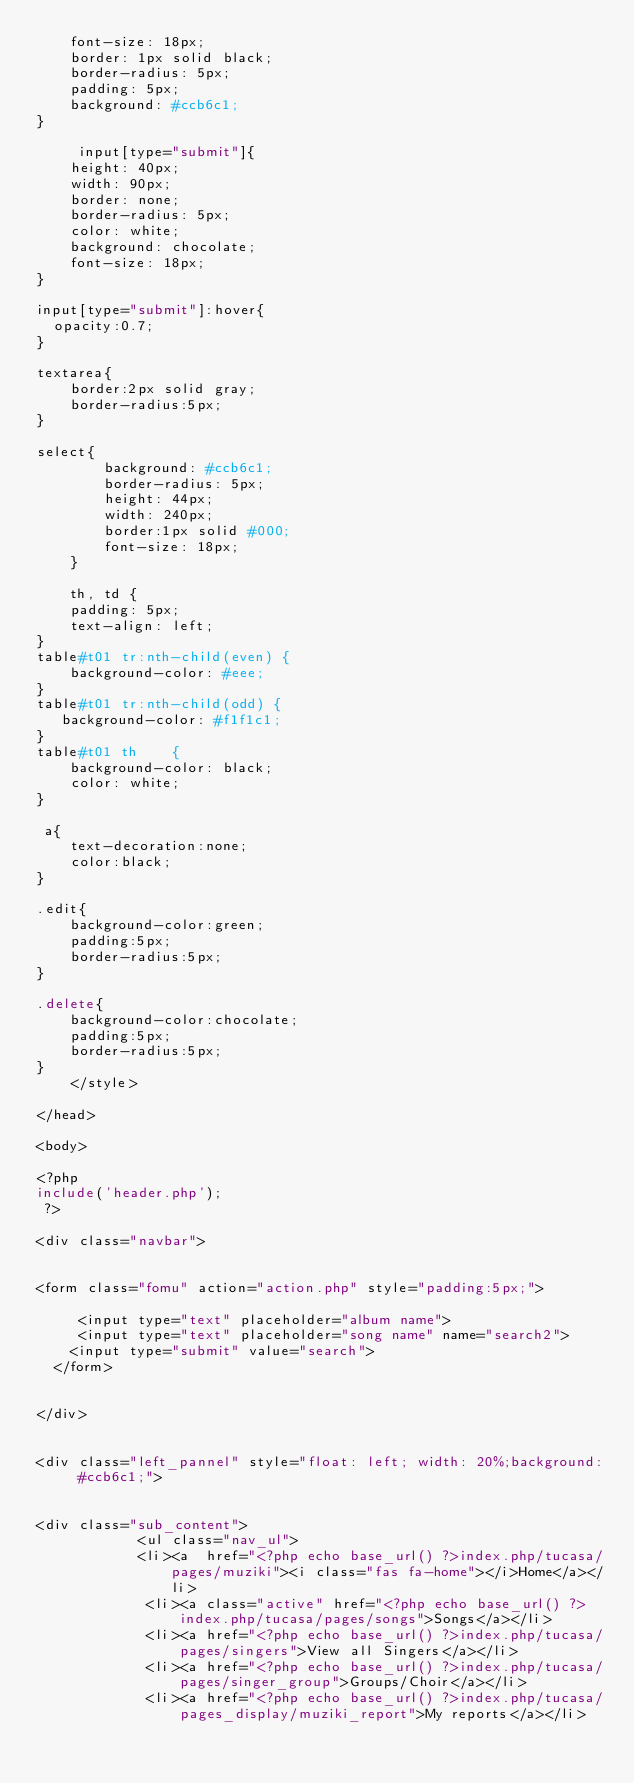<code> <loc_0><loc_0><loc_500><loc_500><_PHP_>    font-size: 18px;
    border: 1px solid black;
    border-radius: 5px;
    padding: 5px;
    background: #ccb6c1;
}

     input[type="submit"]{
    height: 40px;
    width: 90px;
    border: none;
    border-radius: 5px;
    color: white;
    background: chocolate;
    font-size: 18px;
}

input[type="submit"]:hover{
  opacity:0.7;
}

textarea{
    border:2px solid gray;
    border-radius:5px;
}
       
select{
        background: #ccb6c1;
        border-radius: 5px;
        height: 44px;
        width: 240px;
        border:1px solid #000;
        font-size: 18px;
    }

    th, td {
    padding: 5px;
    text-align: left;
}
table#t01 tr:nth-child(even) {
    background-color: #eee;
}
table#t01 tr:nth-child(odd) {
   background-color: #f1f1c1;
}
table#t01 th	{
    background-color: black;
    color: white;
}

 a{
    text-decoration:none;
    color:black;
}

.edit{
    background-color:green;
    padding:5px;
    border-radius:5px;
}

.delete{
    background-color:chocolate;
    padding:5px;
    border-radius:5px;
}
    </style>

</head>

<body>
 
<?php
include('header.php');
 ?>

<div class="navbar">


<form class="fomu" action="action.php" style="padding:5px;">

     <input type="text" placeholder="album name">
     <input type="text" placeholder="song name" name="search2">
	<input type="submit" value="search">
  </form>


</div>


<div class="left_pannel" style="float: left; width: 20%;background: #ccb6c1;">


<div class="sub_content">
            <ul class="nav_ul">
            <li><a  href="<?php echo base_url() ?>index.php/tucasa/pages/muziki"><i class="fas fa-home"></i>Home</a></li>
             <li><a class="active" href="<?php echo base_url() ?>index.php/tucasa/pages/songs">Songs</a></li>
             <li><a href="<?php echo base_url() ?>index.php/tucasa/pages/singers">View all Singers</a></li>
             <li><a href="<?php echo base_url() ?>index.php/tucasa/pages/singer_group">Groups/Choir</a></li>
             <li><a href="<?php echo base_url() ?>index.php/tucasa/pages_display/muziki_report">My reports</a></li></code> 